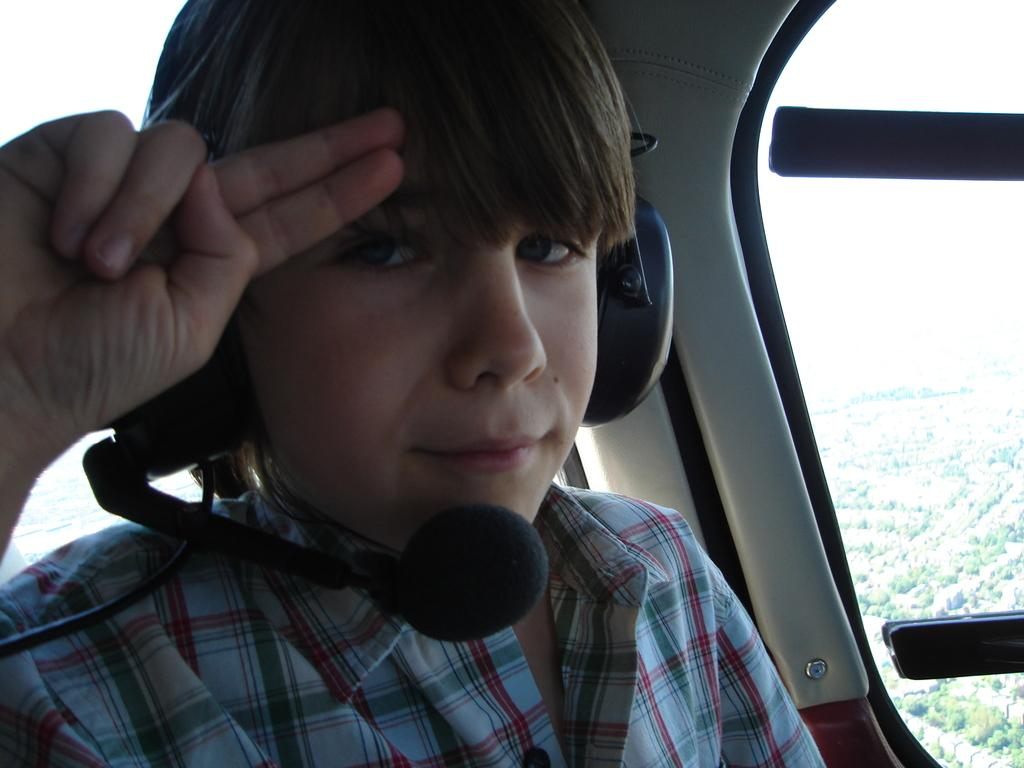Who is in the picture? There is a boy in the picture. What is the boy wearing? The boy is wearing microphone headsets. What is the boy doing in the picture? The boy is saluting. What can be seen in the background of the picture? Trees are visible in the background of the picture. Is there any architectural feature in the picture? Yes, there is a window in the picture. What type of pin is the boy holding in the picture? There is no pin visible in the picture; the boy is wearing microphone headsets and saluting. What kind of poison is the boy using in the picture? There is no poison present in the picture; the boy is wearing microphone headsets and saluting. 